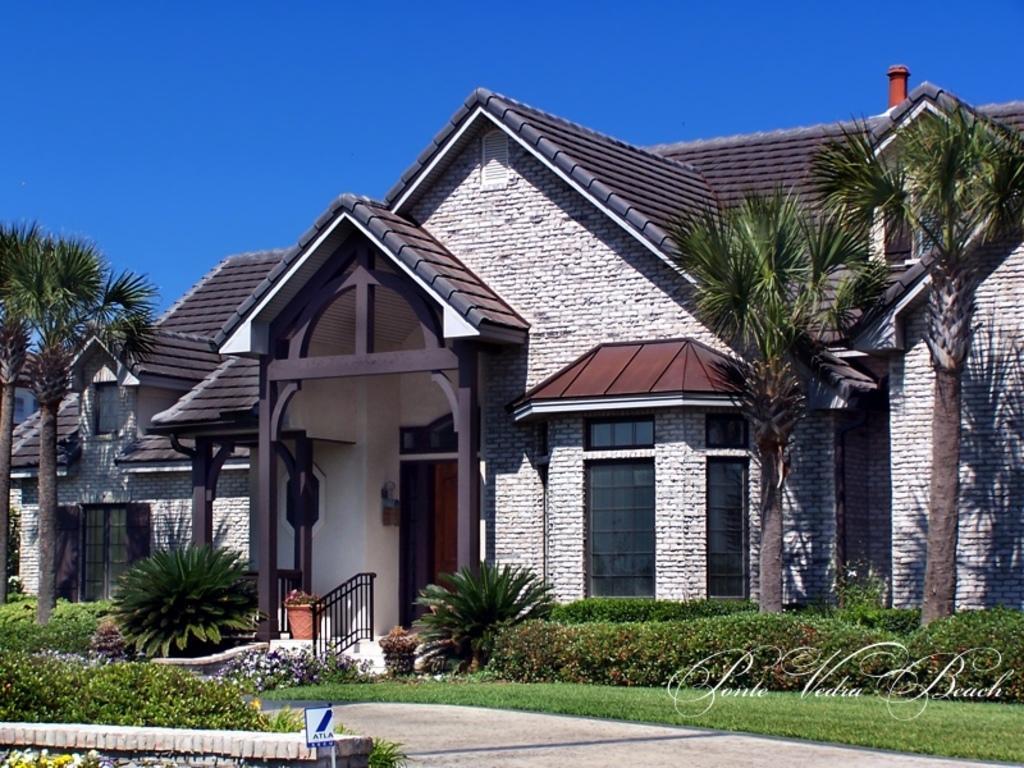In one or two sentences, can you explain what this image depicts? In the picture I can see a house. Here I can see the grass, plants, fence, trees and some other objects. In the background I can see the sky. On the bottom right side of the image I can see a watermark. 